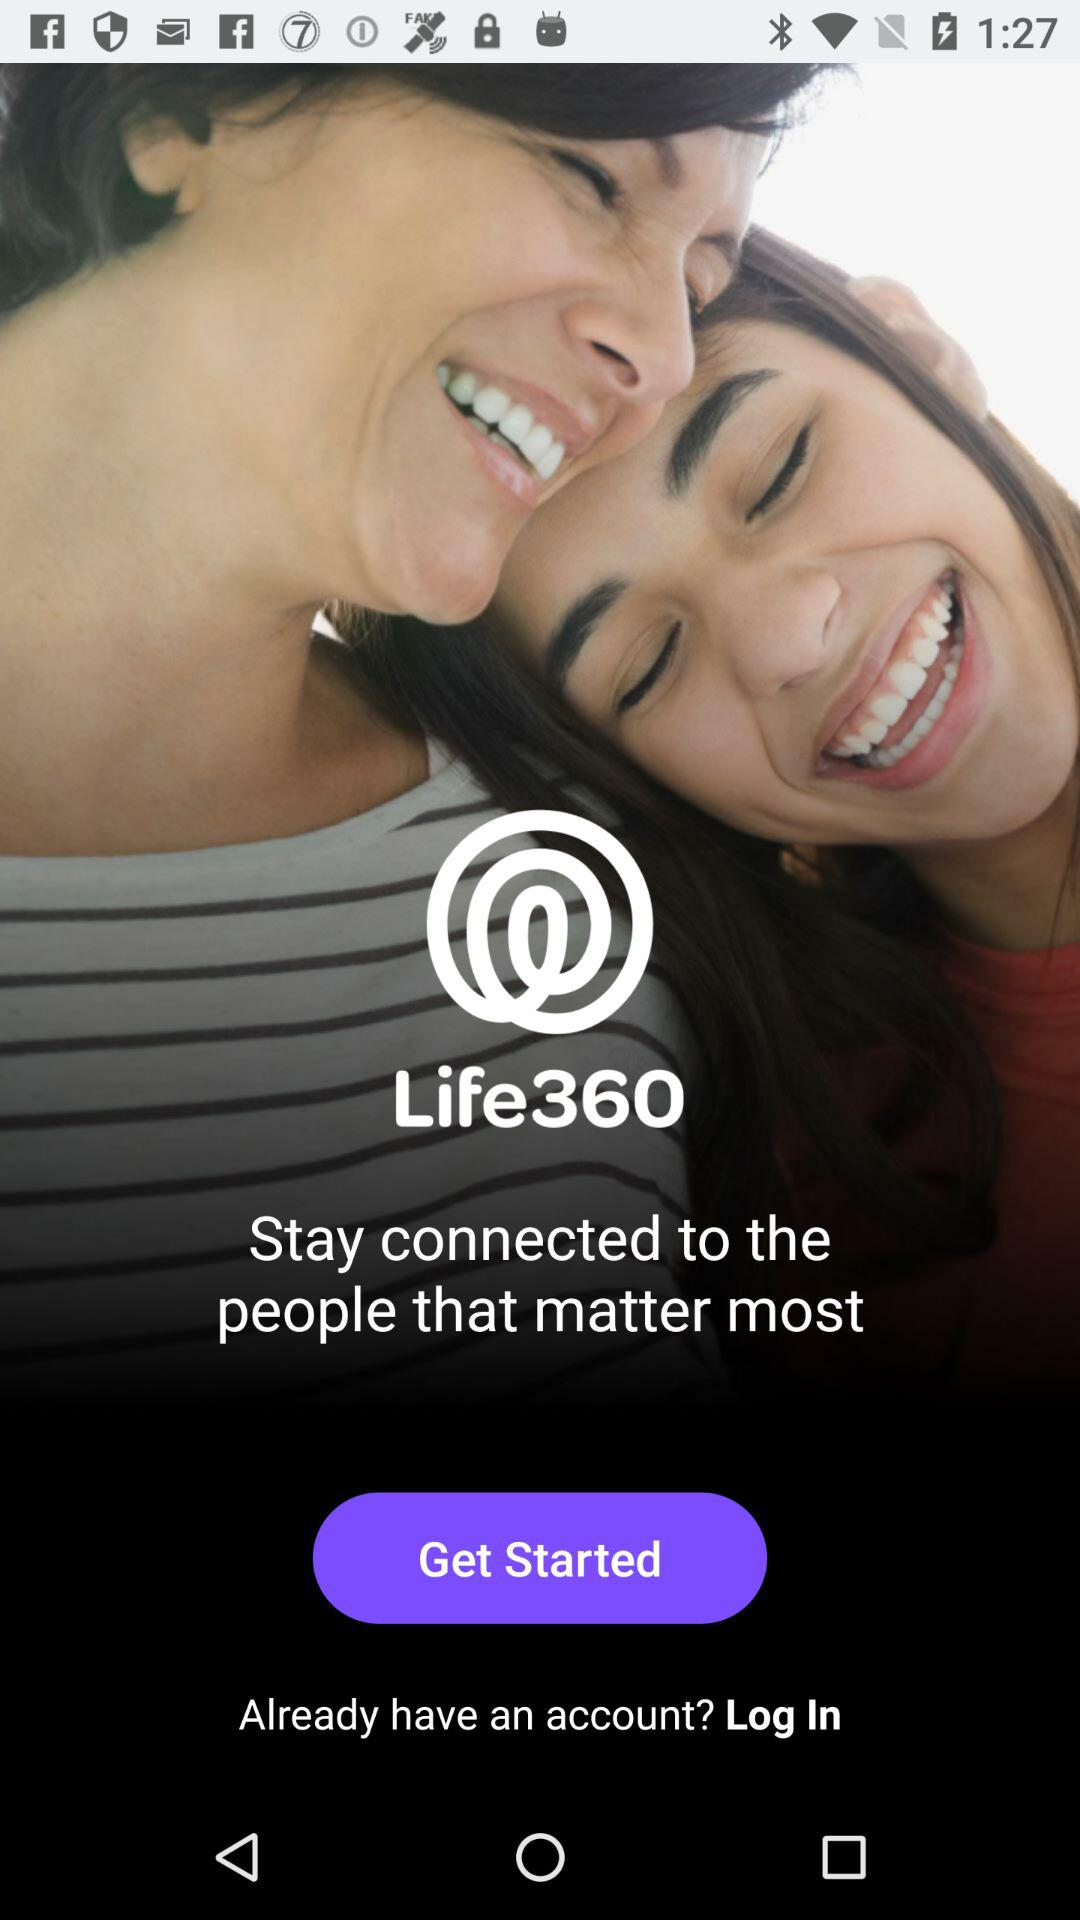What is the name of the application? The name of the application is "Life360". 